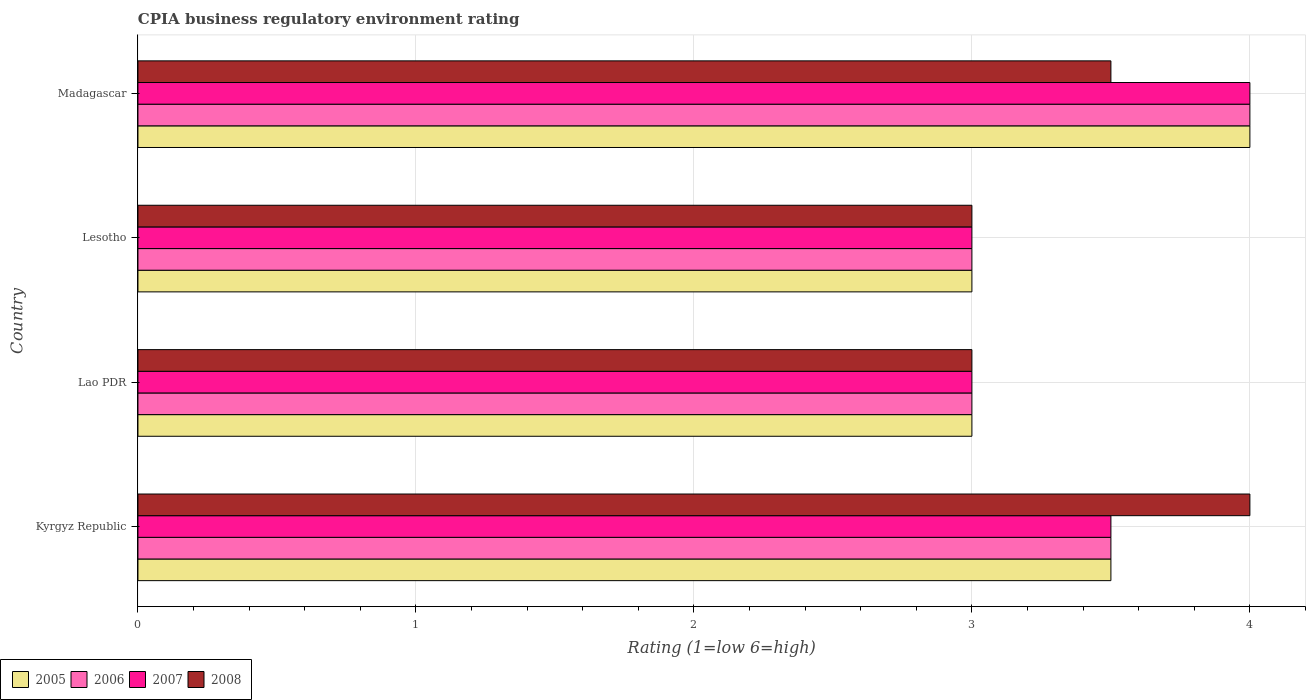How many groups of bars are there?
Offer a very short reply. 4. Are the number of bars per tick equal to the number of legend labels?
Make the answer very short. Yes. How many bars are there on the 1st tick from the top?
Keep it short and to the point. 4. How many bars are there on the 4th tick from the bottom?
Keep it short and to the point. 4. What is the label of the 2nd group of bars from the top?
Give a very brief answer. Lesotho. In how many cases, is the number of bars for a given country not equal to the number of legend labels?
Keep it short and to the point. 0. What is the CPIA rating in 2007 in Lesotho?
Provide a succinct answer. 3. Across all countries, what is the maximum CPIA rating in 2006?
Make the answer very short. 4. In which country was the CPIA rating in 2005 maximum?
Your response must be concise. Madagascar. In which country was the CPIA rating in 2008 minimum?
Your response must be concise. Lao PDR. What is the average CPIA rating in 2006 per country?
Keep it short and to the point. 3.38. What is the ratio of the CPIA rating in 2007 in Kyrgyz Republic to that in Lesotho?
Your answer should be very brief. 1.17. What is the difference between the highest and the second highest CPIA rating in 2007?
Provide a succinct answer. 0.5. What is the difference between the highest and the lowest CPIA rating in 2005?
Make the answer very short. 1. Is the sum of the CPIA rating in 2005 in Kyrgyz Republic and Lesotho greater than the maximum CPIA rating in 2007 across all countries?
Offer a very short reply. Yes. What does the 4th bar from the top in Lao PDR represents?
Your answer should be very brief. 2005. What does the 1st bar from the bottom in Lao PDR represents?
Give a very brief answer. 2005. Is it the case that in every country, the sum of the CPIA rating in 2006 and CPIA rating in 2007 is greater than the CPIA rating in 2005?
Offer a terse response. Yes. How many bars are there?
Offer a very short reply. 16. How many countries are there in the graph?
Provide a short and direct response. 4. What is the difference between two consecutive major ticks on the X-axis?
Give a very brief answer. 1. Are the values on the major ticks of X-axis written in scientific E-notation?
Your answer should be very brief. No. Does the graph contain grids?
Offer a very short reply. Yes. Where does the legend appear in the graph?
Provide a short and direct response. Bottom left. How many legend labels are there?
Ensure brevity in your answer.  4. How are the legend labels stacked?
Provide a succinct answer. Horizontal. What is the title of the graph?
Make the answer very short. CPIA business regulatory environment rating. Does "2002" appear as one of the legend labels in the graph?
Your response must be concise. No. What is the Rating (1=low 6=high) of 2005 in Kyrgyz Republic?
Your answer should be compact. 3.5. What is the Rating (1=low 6=high) of 2006 in Kyrgyz Republic?
Provide a succinct answer. 3.5. What is the Rating (1=low 6=high) in 2007 in Kyrgyz Republic?
Give a very brief answer. 3.5. What is the Rating (1=low 6=high) of 2005 in Lao PDR?
Your answer should be compact. 3. What is the Rating (1=low 6=high) of 2006 in Lao PDR?
Your response must be concise. 3. What is the Rating (1=low 6=high) in 2008 in Lao PDR?
Give a very brief answer. 3. What is the Rating (1=low 6=high) in 2005 in Lesotho?
Offer a terse response. 3. What is the Rating (1=low 6=high) of 2007 in Lesotho?
Offer a very short reply. 3. What is the Rating (1=low 6=high) of 2006 in Madagascar?
Provide a succinct answer. 4. What is the Rating (1=low 6=high) in 2007 in Madagascar?
Your answer should be very brief. 4. Across all countries, what is the maximum Rating (1=low 6=high) in 2007?
Your response must be concise. 4. Across all countries, what is the minimum Rating (1=low 6=high) of 2006?
Ensure brevity in your answer.  3. Across all countries, what is the minimum Rating (1=low 6=high) of 2008?
Your response must be concise. 3. What is the total Rating (1=low 6=high) in 2005 in the graph?
Make the answer very short. 13.5. What is the total Rating (1=low 6=high) in 2006 in the graph?
Provide a succinct answer. 13.5. What is the total Rating (1=low 6=high) in 2007 in the graph?
Make the answer very short. 13.5. What is the difference between the Rating (1=low 6=high) in 2005 in Kyrgyz Republic and that in Lao PDR?
Make the answer very short. 0.5. What is the difference between the Rating (1=low 6=high) of 2007 in Kyrgyz Republic and that in Lao PDR?
Offer a terse response. 0.5. What is the difference between the Rating (1=low 6=high) of 2005 in Kyrgyz Republic and that in Lesotho?
Provide a short and direct response. 0.5. What is the difference between the Rating (1=low 6=high) in 2006 in Kyrgyz Republic and that in Lesotho?
Give a very brief answer. 0.5. What is the difference between the Rating (1=low 6=high) of 2007 in Kyrgyz Republic and that in Lesotho?
Ensure brevity in your answer.  0.5. What is the difference between the Rating (1=low 6=high) in 2005 in Kyrgyz Republic and that in Madagascar?
Give a very brief answer. -0.5. What is the difference between the Rating (1=low 6=high) of 2006 in Kyrgyz Republic and that in Madagascar?
Provide a short and direct response. -0.5. What is the difference between the Rating (1=low 6=high) of 2007 in Lao PDR and that in Lesotho?
Make the answer very short. 0. What is the difference between the Rating (1=low 6=high) of 2007 in Lesotho and that in Madagascar?
Give a very brief answer. -1. What is the difference between the Rating (1=low 6=high) of 2008 in Lesotho and that in Madagascar?
Your response must be concise. -0.5. What is the difference between the Rating (1=low 6=high) in 2005 in Kyrgyz Republic and the Rating (1=low 6=high) in 2007 in Lao PDR?
Your answer should be compact. 0.5. What is the difference between the Rating (1=low 6=high) in 2005 in Kyrgyz Republic and the Rating (1=low 6=high) in 2008 in Lao PDR?
Give a very brief answer. 0.5. What is the difference between the Rating (1=low 6=high) of 2005 in Kyrgyz Republic and the Rating (1=low 6=high) of 2006 in Lesotho?
Offer a terse response. 0.5. What is the difference between the Rating (1=low 6=high) of 2005 in Kyrgyz Republic and the Rating (1=low 6=high) of 2007 in Lesotho?
Give a very brief answer. 0.5. What is the difference between the Rating (1=low 6=high) in 2005 in Kyrgyz Republic and the Rating (1=low 6=high) in 2008 in Lesotho?
Provide a succinct answer. 0.5. What is the difference between the Rating (1=low 6=high) of 2006 in Kyrgyz Republic and the Rating (1=low 6=high) of 2008 in Lesotho?
Keep it short and to the point. 0.5. What is the difference between the Rating (1=low 6=high) in 2007 in Kyrgyz Republic and the Rating (1=low 6=high) in 2008 in Lesotho?
Your answer should be very brief. 0.5. What is the difference between the Rating (1=low 6=high) of 2005 in Kyrgyz Republic and the Rating (1=low 6=high) of 2006 in Madagascar?
Ensure brevity in your answer.  -0.5. What is the difference between the Rating (1=low 6=high) of 2006 in Kyrgyz Republic and the Rating (1=low 6=high) of 2007 in Madagascar?
Ensure brevity in your answer.  -0.5. What is the difference between the Rating (1=low 6=high) in 2006 in Kyrgyz Republic and the Rating (1=low 6=high) in 2008 in Madagascar?
Offer a terse response. 0. What is the difference between the Rating (1=low 6=high) in 2007 in Kyrgyz Republic and the Rating (1=low 6=high) in 2008 in Madagascar?
Your response must be concise. 0. What is the difference between the Rating (1=low 6=high) of 2005 in Lao PDR and the Rating (1=low 6=high) of 2006 in Lesotho?
Offer a very short reply. 0. What is the difference between the Rating (1=low 6=high) in 2005 in Lao PDR and the Rating (1=low 6=high) in 2008 in Lesotho?
Offer a very short reply. 0. What is the difference between the Rating (1=low 6=high) in 2006 in Lao PDR and the Rating (1=low 6=high) in 2007 in Lesotho?
Provide a succinct answer. 0. What is the difference between the Rating (1=low 6=high) of 2007 in Lao PDR and the Rating (1=low 6=high) of 2008 in Lesotho?
Keep it short and to the point. 0. What is the difference between the Rating (1=low 6=high) in 2006 in Lao PDR and the Rating (1=low 6=high) in 2007 in Madagascar?
Provide a succinct answer. -1. What is the difference between the Rating (1=low 6=high) in 2005 in Lesotho and the Rating (1=low 6=high) in 2006 in Madagascar?
Offer a very short reply. -1. What is the difference between the Rating (1=low 6=high) in 2006 in Lesotho and the Rating (1=low 6=high) in 2008 in Madagascar?
Offer a very short reply. -0.5. What is the average Rating (1=low 6=high) of 2005 per country?
Ensure brevity in your answer.  3.38. What is the average Rating (1=low 6=high) in 2006 per country?
Your answer should be compact. 3.38. What is the average Rating (1=low 6=high) of 2007 per country?
Ensure brevity in your answer.  3.38. What is the average Rating (1=low 6=high) in 2008 per country?
Your answer should be compact. 3.38. What is the difference between the Rating (1=low 6=high) in 2005 and Rating (1=low 6=high) in 2007 in Kyrgyz Republic?
Provide a succinct answer. 0. What is the difference between the Rating (1=low 6=high) in 2005 and Rating (1=low 6=high) in 2008 in Kyrgyz Republic?
Your response must be concise. -0.5. What is the difference between the Rating (1=low 6=high) of 2006 and Rating (1=low 6=high) of 2007 in Kyrgyz Republic?
Offer a terse response. 0. What is the difference between the Rating (1=low 6=high) of 2006 and Rating (1=low 6=high) of 2008 in Kyrgyz Republic?
Offer a very short reply. -0.5. What is the difference between the Rating (1=low 6=high) of 2007 and Rating (1=low 6=high) of 2008 in Kyrgyz Republic?
Your answer should be compact. -0.5. What is the difference between the Rating (1=low 6=high) in 2006 and Rating (1=low 6=high) in 2008 in Lao PDR?
Your answer should be compact. 0. What is the difference between the Rating (1=low 6=high) of 2005 and Rating (1=low 6=high) of 2006 in Lesotho?
Keep it short and to the point. 0. What is the difference between the Rating (1=low 6=high) of 2005 and Rating (1=low 6=high) of 2008 in Lesotho?
Your response must be concise. 0. What is the difference between the Rating (1=low 6=high) of 2006 and Rating (1=low 6=high) of 2007 in Lesotho?
Your response must be concise. 0. What is the difference between the Rating (1=low 6=high) in 2006 and Rating (1=low 6=high) in 2008 in Lesotho?
Ensure brevity in your answer.  0. What is the ratio of the Rating (1=low 6=high) of 2005 in Kyrgyz Republic to that in Lao PDR?
Your answer should be very brief. 1.17. What is the ratio of the Rating (1=low 6=high) of 2006 in Kyrgyz Republic to that in Lao PDR?
Make the answer very short. 1.17. What is the ratio of the Rating (1=low 6=high) in 2007 in Kyrgyz Republic to that in Lao PDR?
Your answer should be compact. 1.17. What is the ratio of the Rating (1=low 6=high) of 2008 in Kyrgyz Republic to that in Lao PDR?
Your answer should be compact. 1.33. What is the ratio of the Rating (1=low 6=high) in 2006 in Kyrgyz Republic to that in Lesotho?
Offer a very short reply. 1.17. What is the ratio of the Rating (1=low 6=high) of 2007 in Kyrgyz Republic to that in Lesotho?
Make the answer very short. 1.17. What is the ratio of the Rating (1=low 6=high) in 2008 in Kyrgyz Republic to that in Madagascar?
Your response must be concise. 1.14. What is the ratio of the Rating (1=low 6=high) in 2005 in Lao PDR to that in Lesotho?
Your answer should be very brief. 1. What is the ratio of the Rating (1=low 6=high) of 2006 in Lao PDR to that in Lesotho?
Your answer should be very brief. 1. What is the ratio of the Rating (1=low 6=high) of 2008 in Lao PDR to that in Lesotho?
Provide a short and direct response. 1. What is the ratio of the Rating (1=low 6=high) in 2005 in Lao PDR to that in Madagascar?
Your answer should be very brief. 0.75. What is the ratio of the Rating (1=low 6=high) of 2007 in Lao PDR to that in Madagascar?
Your answer should be compact. 0.75. What is the ratio of the Rating (1=low 6=high) in 2006 in Lesotho to that in Madagascar?
Your answer should be compact. 0.75. What is the ratio of the Rating (1=low 6=high) in 2007 in Lesotho to that in Madagascar?
Offer a very short reply. 0.75. What is the difference between the highest and the second highest Rating (1=low 6=high) in 2006?
Your answer should be compact. 0.5. What is the difference between the highest and the second highest Rating (1=low 6=high) of 2008?
Provide a succinct answer. 0.5. What is the difference between the highest and the lowest Rating (1=low 6=high) in 2005?
Your answer should be very brief. 1. What is the difference between the highest and the lowest Rating (1=low 6=high) in 2007?
Your answer should be very brief. 1. 